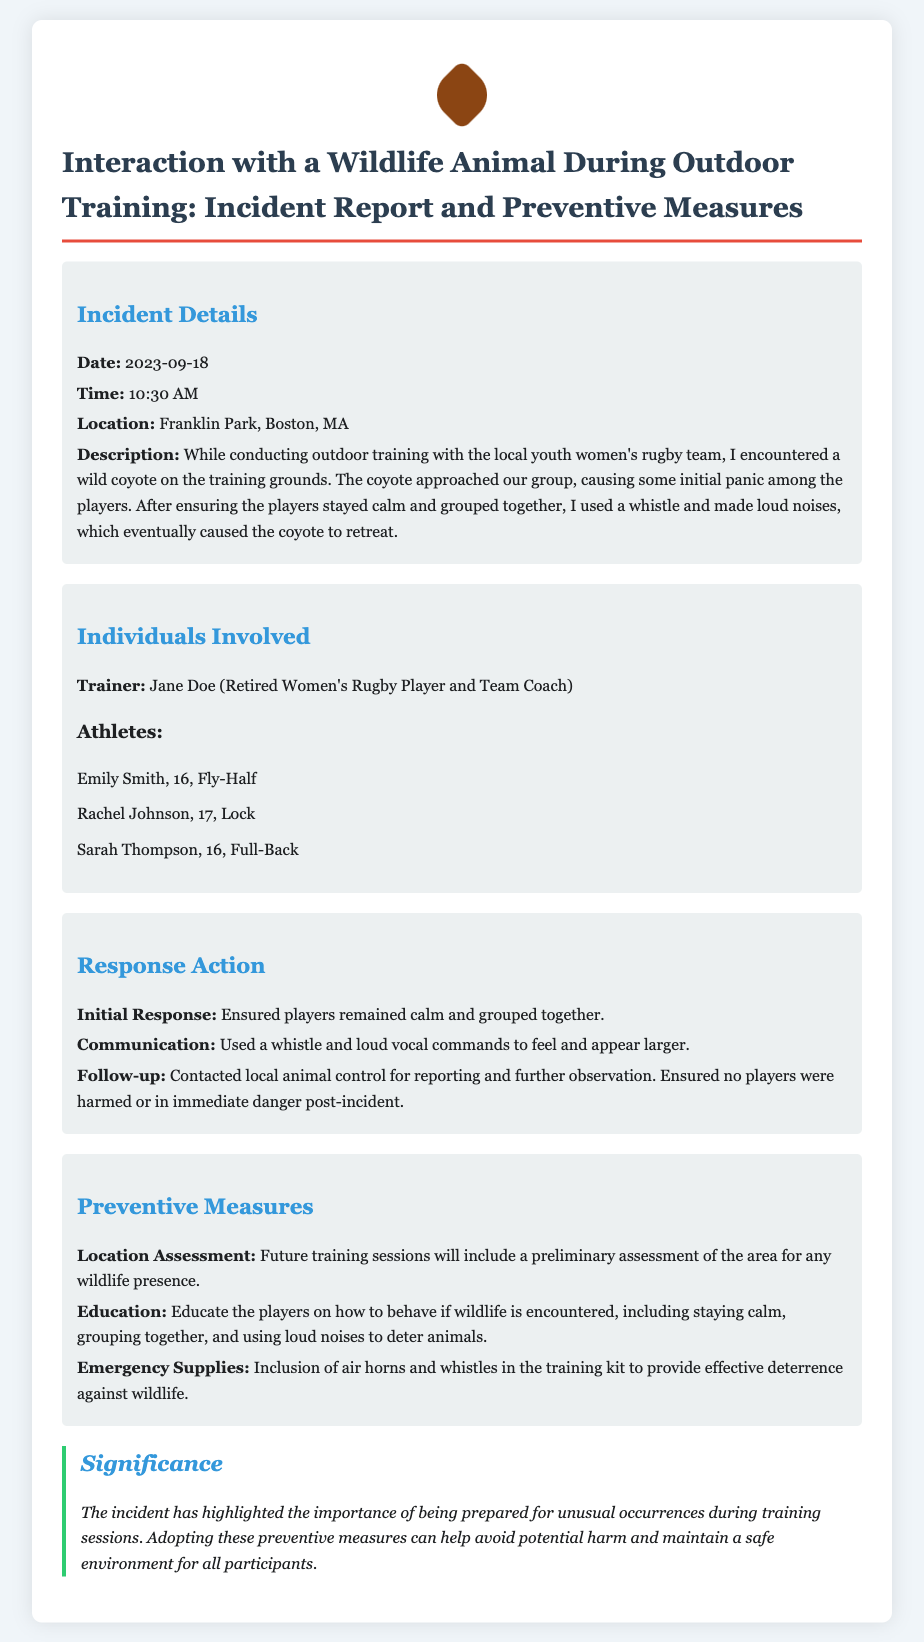what was the date of the incident? The date of the incident is explicitly stated in the document.
Answer: 2023-09-18 who was the trainer involved in the incident? The document identifies the trainer involved in the incident as Jane Doe.
Answer: Jane Doe what wild animal was encountered during training? The document refers to the specific animal involved in the incident.
Answer: coyote what location did the incident occur? The incident report specifies the location where the incident took place.
Answer: Franklin Park, Boston, MA how did the trainer initially respond to the situation? The initial response detailed in the document indicates the action taken by the trainer.
Answer: Ensured players remained calm and grouped together what is one preventive measure mentioned in the report? The report outlines specific actions to be taken to prevent similar incidents in the future.
Answer: Education how did the trainer communicate with the coyote? The document describes the method used by the trainer to manage the situation with the coyote.
Answer: Used a whistle and loud vocal commands what type of training kit items will be included for emergency situations? The document lists specific items to be added to the emergency supplies in the training kit.
Answer: air horns and whistles what is the significance of this incident highlighted in the report? The report emphasizes the importance of a certain aspect following the incident.
Answer: importance of being prepared 